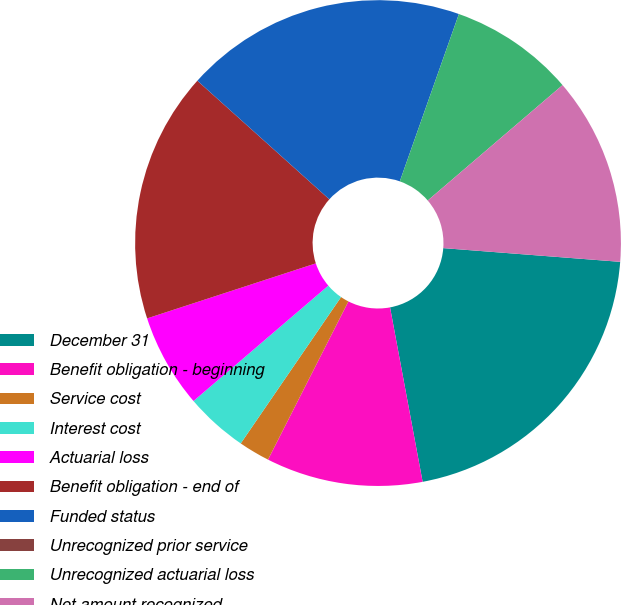Convert chart. <chart><loc_0><loc_0><loc_500><loc_500><pie_chart><fcel>December 31<fcel>Benefit obligation - beginning<fcel>Service cost<fcel>Interest cost<fcel>Actuarial loss<fcel>Benefit obligation - end of<fcel>Funded status<fcel>Unrecognized prior service<fcel>Unrecognized actuarial loss<fcel>Net amount recognized<nl><fcel>20.83%<fcel>10.42%<fcel>2.08%<fcel>4.17%<fcel>6.25%<fcel>16.67%<fcel>18.75%<fcel>0.0%<fcel>8.33%<fcel>12.5%<nl></chart> 